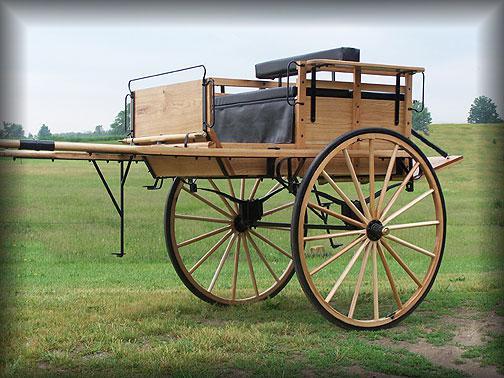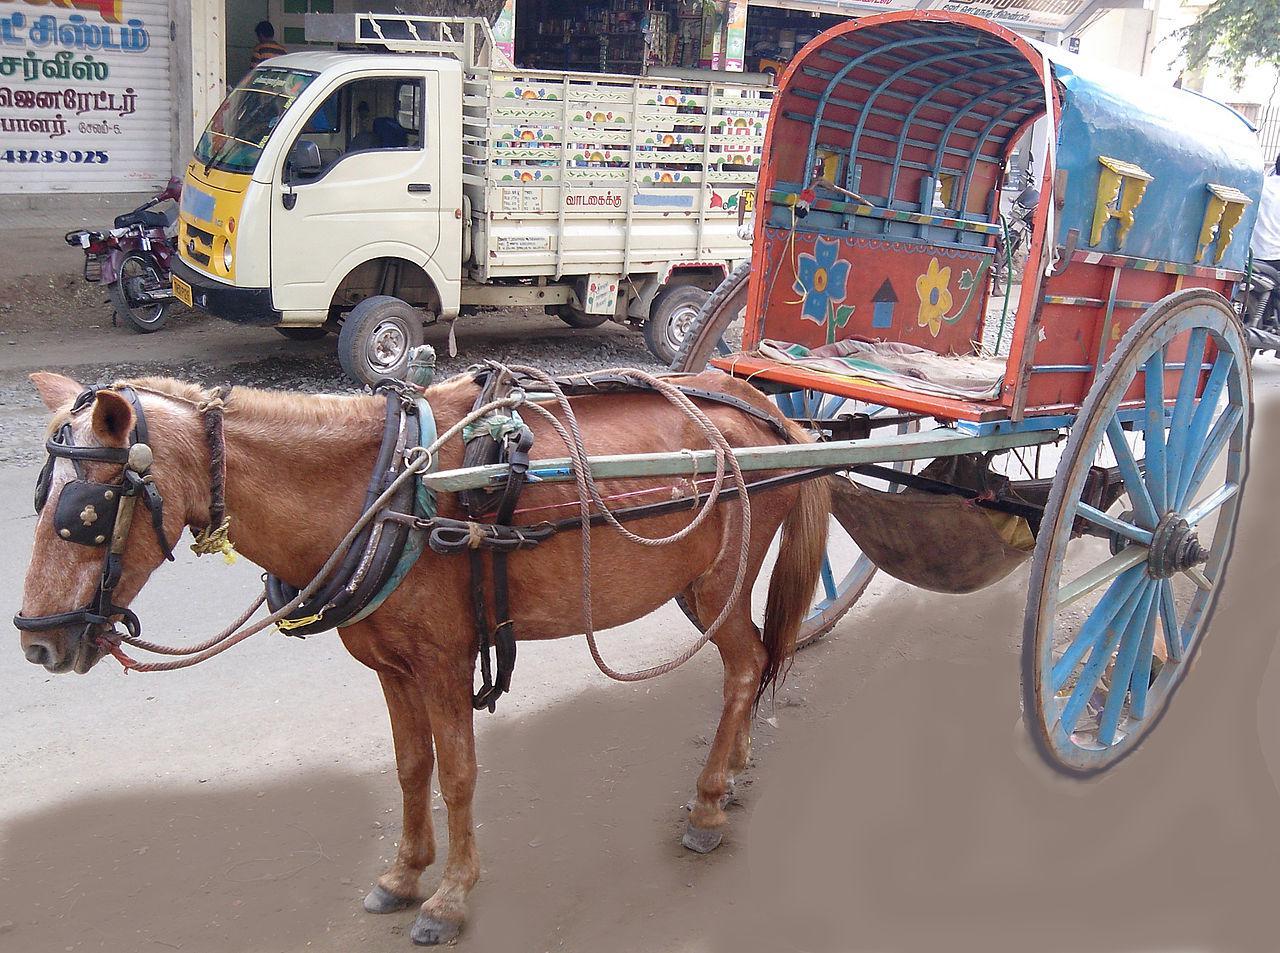The first image is the image on the left, the second image is the image on the right. Examine the images to the left and right. Is the description "Each image shows a wagon hitched to a brown horse." accurate? Answer yes or no. No. 